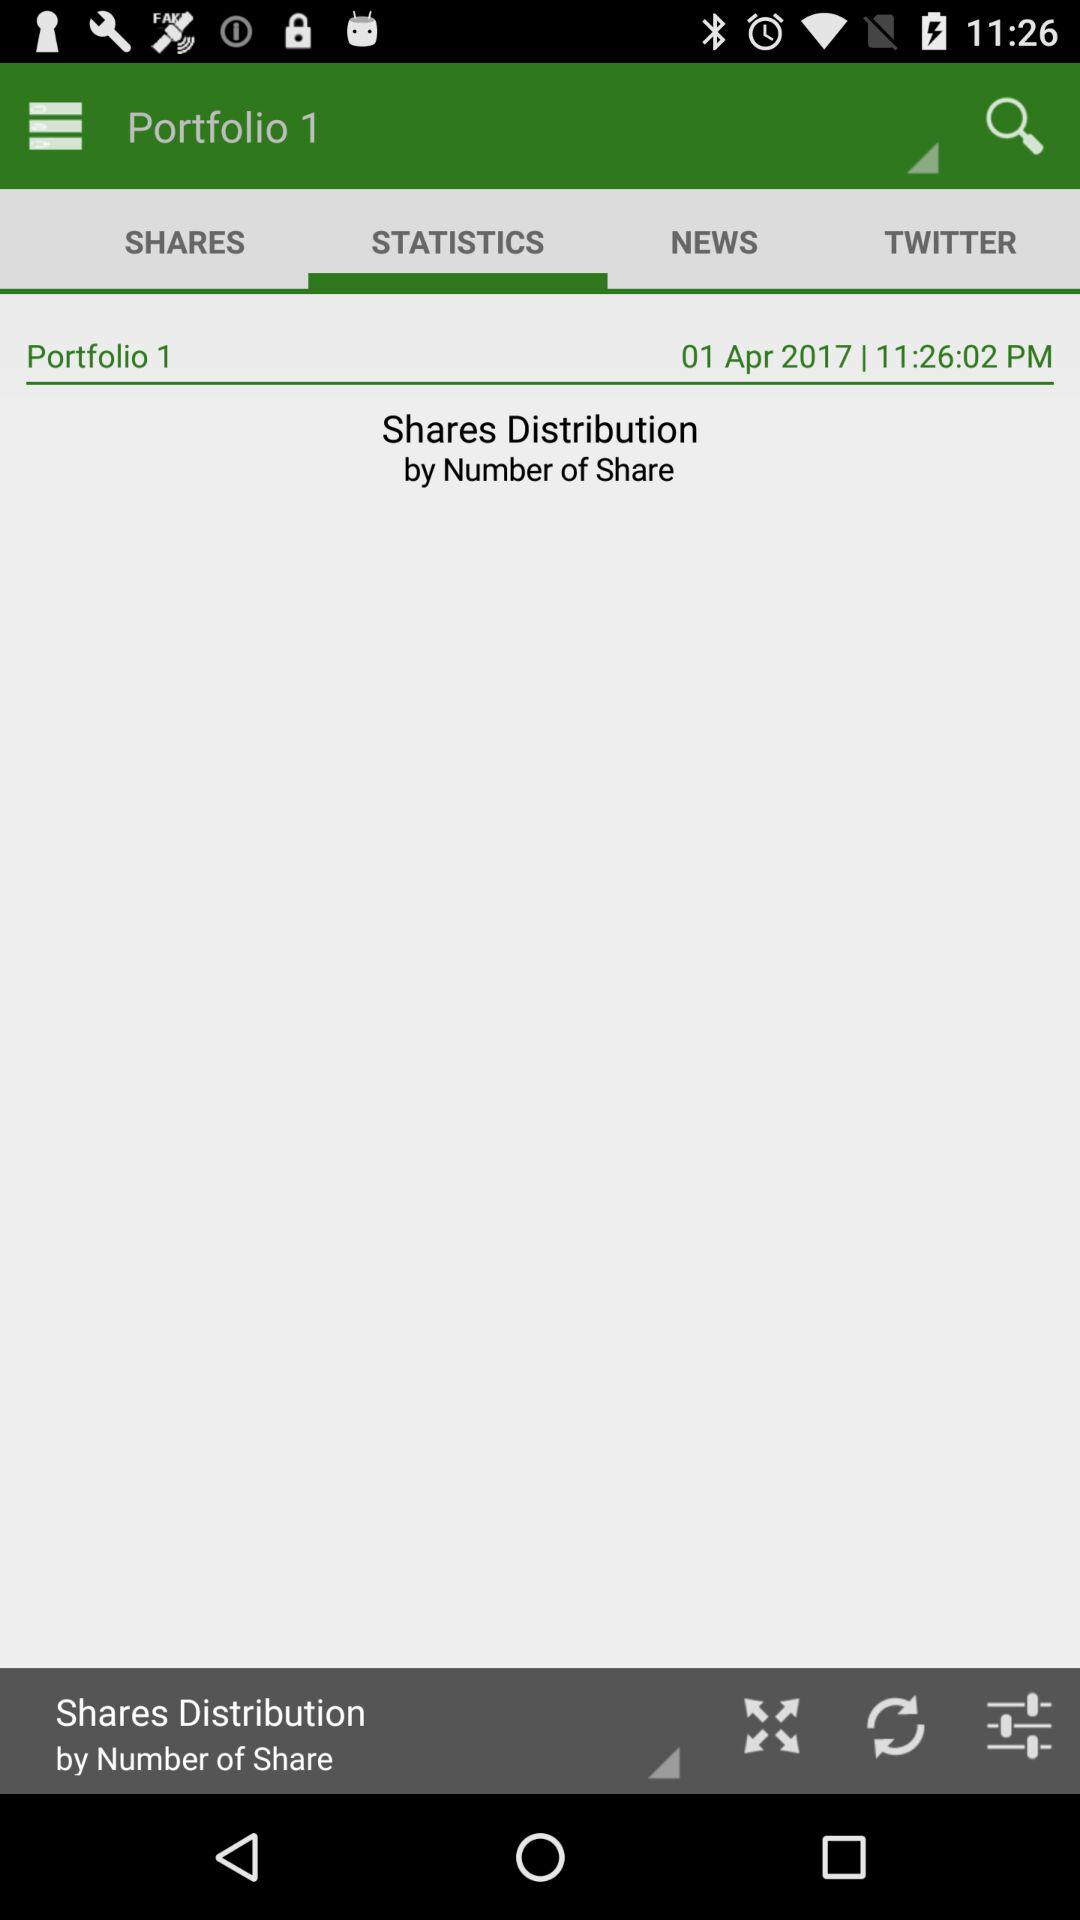What is the given date? The given date is April 1, 2017. 